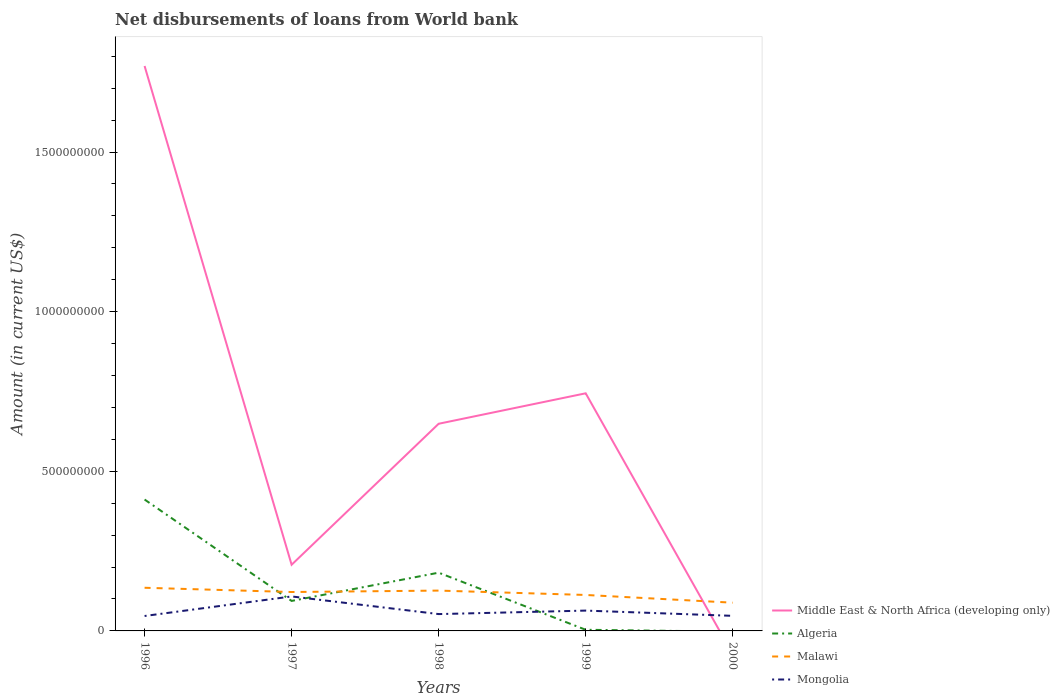How many different coloured lines are there?
Provide a short and direct response. 4. Across all years, what is the maximum amount of loan disbursed from World Bank in Algeria?
Your response must be concise. 0. What is the total amount of loan disbursed from World Bank in Middle East & North Africa (developing only) in the graph?
Your answer should be compact. 1.56e+09. What is the difference between the highest and the second highest amount of loan disbursed from World Bank in Algeria?
Make the answer very short. 4.12e+08. How many lines are there?
Provide a succinct answer. 4. What is the difference between two consecutive major ticks on the Y-axis?
Keep it short and to the point. 5.00e+08. Does the graph contain grids?
Provide a succinct answer. No. Where does the legend appear in the graph?
Provide a short and direct response. Bottom right. How many legend labels are there?
Ensure brevity in your answer.  4. What is the title of the graph?
Give a very brief answer. Net disbursements of loans from World bank. What is the Amount (in current US$) of Middle East & North Africa (developing only) in 1996?
Provide a succinct answer. 1.77e+09. What is the Amount (in current US$) of Algeria in 1996?
Keep it short and to the point. 4.12e+08. What is the Amount (in current US$) of Malawi in 1996?
Your answer should be compact. 1.35e+08. What is the Amount (in current US$) of Mongolia in 1996?
Offer a terse response. 4.68e+07. What is the Amount (in current US$) in Middle East & North Africa (developing only) in 1997?
Your answer should be compact. 2.07e+08. What is the Amount (in current US$) in Algeria in 1997?
Offer a very short reply. 9.40e+07. What is the Amount (in current US$) of Malawi in 1997?
Your answer should be compact. 1.22e+08. What is the Amount (in current US$) of Mongolia in 1997?
Give a very brief answer. 1.08e+08. What is the Amount (in current US$) in Middle East & North Africa (developing only) in 1998?
Make the answer very short. 6.49e+08. What is the Amount (in current US$) in Algeria in 1998?
Keep it short and to the point. 1.82e+08. What is the Amount (in current US$) of Malawi in 1998?
Your answer should be compact. 1.26e+08. What is the Amount (in current US$) of Mongolia in 1998?
Offer a very short reply. 5.27e+07. What is the Amount (in current US$) of Middle East & North Africa (developing only) in 1999?
Provide a short and direct response. 7.44e+08. What is the Amount (in current US$) of Algeria in 1999?
Keep it short and to the point. 3.60e+06. What is the Amount (in current US$) in Malawi in 1999?
Give a very brief answer. 1.13e+08. What is the Amount (in current US$) of Mongolia in 1999?
Make the answer very short. 6.37e+07. What is the Amount (in current US$) of Algeria in 2000?
Your answer should be very brief. 0. What is the Amount (in current US$) of Malawi in 2000?
Your answer should be compact. 8.84e+07. What is the Amount (in current US$) in Mongolia in 2000?
Your answer should be compact. 4.72e+07. Across all years, what is the maximum Amount (in current US$) of Middle East & North Africa (developing only)?
Ensure brevity in your answer.  1.77e+09. Across all years, what is the maximum Amount (in current US$) of Algeria?
Your answer should be compact. 4.12e+08. Across all years, what is the maximum Amount (in current US$) of Malawi?
Your response must be concise. 1.35e+08. Across all years, what is the maximum Amount (in current US$) of Mongolia?
Keep it short and to the point. 1.08e+08. Across all years, what is the minimum Amount (in current US$) of Algeria?
Keep it short and to the point. 0. Across all years, what is the minimum Amount (in current US$) in Malawi?
Your response must be concise. 8.84e+07. Across all years, what is the minimum Amount (in current US$) in Mongolia?
Make the answer very short. 4.68e+07. What is the total Amount (in current US$) of Middle East & North Africa (developing only) in the graph?
Give a very brief answer. 3.37e+09. What is the total Amount (in current US$) of Algeria in the graph?
Make the answer very short. 6.92e+08. What is the total Amount (in current US$) in Malawi in the graph?
Give a very brief answer. 5.84e+08. What is the total Amount (in current US$) in Mongolia in the graph?
Offer a terse response. 3.18e+08. What is the difference between the Amount (in current US$) of Middle East & North Africa (developing only) in 1996 and that in 1997?
Your response must be concise. 1.56e+09. What is the difference between the Amount (in current US$) in Algeria in 1996 and that in 1997?
Your response must be concise. 3.18e+08. What is the difference between the Amount (in current US$) in Malawi in 1996 and that in 1997?
Provide a succinct answer. 1.33e+07. What is the difference between the Amount (in current US$) in Mongolia in 1996 and that in 1997?
Your answer should be compact. -6.12e+07. What is the difference between the Amount (in current US$) in Middle East & North Africa (developing only) in 1996 and that in 1998?
Offer a terse response. 1.12e+09. What is the difference between the Amount (in current US$) in Algeria in 1996 and that in 1998?
Make the answer very short. 2.29e+08. What is the difference between the Amount (in current US$) of Malawi in 1996 and that in 1998?
Ensure brevity in your answer.  8.83e+06. What is the difference between the Amount (in current US$) of Mongolia in 1996 and that in 1998?
Ensure brevity in your answer.  -5.97e+06. What is the difference between the Amount (in current US$) of Middle East & North Africa (developing only) in 1996 and that in 1999?
Offer a terse response. 1.03e+09. What is the difference between the Amount (in current US$) in Algeria in 1996 and that in 1999?
Make the answer very short. 4.08e+08. What is the difference between the Amount (in current US$) in Malawi in 1996 and that in 1999?
Make the answer very short. 2.25e+07. What is the difference between the Amount (in current US$) in Mongolia in 1996 and that in 1999?
Keep it short and to the point. -1.69e+07. What is the difference between the Amount (in current US$) in Malawi in 1996 and that in 2000?
Keep it short and to the point. 4.67e+07. What is the difference between the Amount (in current US$) in Mongolia in 1996 and that in 2000?
Offer a very short reply. -4.84e+05. What is the difference between the Amount (in current US$) in Middle East & North Africa (developing only) in 1997 and that in 1998?
Provide a succinct answer. -4.42e+08. What is the difference between the Amount (in current US$) of Algeria in 1997 and that in 1998?
Ensure brevity in your answer.  -8.85e+07. What is the difference between the Amount (in current US$) of Malawi in 1997 and that in 1998?
Offer a very short reply. -4.47e+06. What is the difference between the Amount (in current US$) of Mongolia in 1997 and that in 1998?
Give a very brief answer. 5.53e+07. What is the difference between the Amount (in current US$) in Middle East & North Africa (developing only) in 1997 and that in 1999?
Your answer should be very brief. -5.37e+08. What is the difference between the Amount (in current US$) in Algeria in 1997 and that in 1999?
Keep it short and to the point. 9.04e+07. What is the difference between the Amount (in current US$) of Malawi in 1997 and that in 1999?
Make the answer very short. 9.22e+06. What is the difference between the Amount (in current US$) in Mongolia in 1997 and that in 1999?
Your answer should be very brief. 4.43e+07. What is the difference between the Amount (in current US$) in Malawi in 1997 and that in 2000?
Ensure brevity in your answer.  3.34e+07. What is the difference between the Amount (in current US$) in Mongolia in 1997 and that in 2000?
Offer a very short reply. 6.07e+07. What is the difference between the Amount (in current US$) of Middle East & North Africa (developing only) in 1998 and that in 1999?
Keep it short and to the point. -9.54e+07. What is the difference between the Amount (in current US$) of Algeria in 1998 and that in 1999?
Provide a succinct answer. 1.79e+08. What is the difference between the Amount (in current US$) of Malawi in 1998 and that in 1999?
Offer a very short reply. 1.37e+07. What is the difference between the Amount (in current US$) in Mongolia in 1998 and that in 1999?
Your answer should be compact. -1.09e+07. What is the difference between the Amount (in current US$) in Malawi in 1998 and that in 2000?
Ensure brevity in your answer.  3.79e+07. What is the difference between the Amount (in current US$) of Mongolia in 1998 and that in 2000?
Provide a succinct answer. 5.49e+06. What is the difference between the Amount (in current US$) of Malawi in 1999 and that in 2000?
Provide a short and direct response. 2.42e+07. What is the difference between the Amount (in current US$) in Mongolia in 1999 and that in 2000?
Make the answer very short. 1.64e+07. What is the difference between the Amount (in current US$) of Middle East & North Africa (developing only) in 1996 and the Amount (in current US$) of Algeria in 1997?
Offer a terse response. 1.68e+09. What is the difference between the Amount (in current US$) of Middle East & North Africa (developing only) in 1996 and the Amount (in current US$) of Malawi in 1997?
Offer a very short reply. 1.65e+09. What is the difference between the Amount (in current US$) in Middle East & North Africa (developing only) in 1996 and the Amount (in current US$) in Mongolia in 1997?
Your answer should be very brief. 1.66e+09. What is the difference between the Amount (in current US$) of Algeria in 1996 and the Amount (in current US$) of Malawi in 1997?
Your response must be concise. 2.90e+08. What is the difference between the Amount (in current US$) of Algeria in 1996 and the Amount (in current US$) of Mongolia in 1997?
Your response must be concise. 3.04e+08. What is the difference between the Amount (in current US$) of Malawi in 1996 and the Amount (in current US$) of Mongolia in 1997?
Your answer should be very brief. 2.72e+07. What is the difference between the Amount (in current US$) in Middle East & North Africa (developing only) in 1996 and the Amount (in current US$) in Algeria in 1998?
Your answer should be very brief. 1.59e+09. What is the difference between the Amount (in current US$) in Middle East & North Africa (developing only) in 1996 and the Amount (in current US$) in Malawi in 1998?
Make the answer very short. 1.64e+09. What is the difference between the Amount (in current US$) of Middle East & North Africa (developing only) in 1996 and the Amount (in current US$) of Mongolia in 1998?
Make the answer very short. 1.72e+09. What is the difference between the Amount (in current US$) in Algeria in 1996 and the Amount (in current US$) in Malawi in 1998?
Make the answer very short. 2.85e+08. What is the difference between the Amount (in current US$) of Algeria in 1996 and the Amount (in current US$) of Mongolia in 1998?
Provide a succinct answer. 3.59e+08. What is the difference between the Amount (in current US$) of Malawi in 1996 and the Amount (in current US$) of Mongolia in 1998?
Make the answer very short. 8.24e+07. What is the difference between the Amount (in current US$) in Middle East & North Africa (developing only) in 1996 and the Amount (in current US$) in Algeria in 1999?
Keep it short and to the point. 1.77e+09. What is the difference between the Amount (in current US$) in Middle East & North Africa (developing only) in 1996 and the Amount (in current US$) in Malawi in 1999?
Provide a short and direct response. 1.66e+09. What is the difference between the Amount (in current US$) of Middle East & North Africa (developing only) in 1996 and the Amount (in current US$) of Mongolia in 1999?
Ensure brevity in your answer.  1.71e+09. What is the difference between the Amount (in current US$) of Algeria in 1996 and the Amount (in current US$) of Malawi in 1999?
Provide a short and direct response. 2.99e+08. What is the difference between the Amount (in current US$) of Algeria in 1996 and the Amount (in current US$) of Mongolia in 1999?
Make the answer very short. 3.48e+08. What is the difference between the Amount (in current US$) in Malawi in 1996 and the Amount (in current US$) in Mongolia in 1999?
Provide a short and direct response. 7.15e+07. What is the difference between the Amount (in current US$) in Middle East & North Africa (developing only) in 1996 and the Amount (in current US$) in Malawi in 2000?
Offer a very short reply. 1.68e+09. What is the difference between the Amount (in current US$) in Middle East & North Africa (developing only) in 1996 and the Amount (in current US$) in Mongolia in 2000?
Provide a short and direct response. 1.72e+09. What is the difference between the Amount (in current US$) of Algeria in 1996 and the Amount (in current US$) of Malawi in 2000?
Your answer should be compact. 3.23e+08. What is the difference between the Amount (in current US$) of Algeria in 1996 and the Amount (in current US$) of Mongolia in 2000?
Offer a very short reply. 3.64e+08. What is the difference between the Amount (in current US$) in Malawi in 1996 and the Amount (in current US$) in Mongolia in 2000?
Ensure brevity in your answer.  8.79e+07. What is the difference between the Amount (in current US$) in Middle East & North Africa (developing only) in 1997 and the Amount (in current US$) in Algeria in 1998?
Offer a terse response. 2.48e+07. What is the difference between the Amount (in current US$) in Middle East & North Africa (developing only) in 1997 and the Amount (in current US$) in Malawi in 1998?
Give a very brief answer. 8.09e+07. What is the difference between the Amount (in current US$) of Middle East & North Africa (developing only) in 1997 and the Amount (in current US$) of Mongolia in 1998?
Provide a short and direct response. 1.55e+08. What is the difference between the Amount (in current US$) of Algeria in 1997 and the Amount (in current US$) of Malawi in 1998?
Your answer should be very brief. -3.24e+07. What is the difference between the Amount (in current US$) of Algeria in 1997 and the Amount (in current US$) of Mongolia in 1998?
Provide a succinct answer. 4.12e+07. What is the difference between the Amount (in current US$) in Malawi in 1997 and the Amount (in current US$) in Mongolia in 1998?
Provide a short and direct response. 6.91e+07. What is the difference between the Amount (in current US$) in Middle East & North Africa (developing only) in 1997 and the Amount (in current US$) in Algeria in 1999?
Provide a succinct answer. 2.04e+08. What is the difference between the Amount (in current US$) of Middle East & North Africa (developing only) in 1997 and the Amount (in current US$) of Malawi in 1999?
Provide a short and direct response. 9.46e+07. What is the difference between the Amount (in current US$) in Middle East & North Africa (developing only) in 1997 and the Amount (in current US$) in Mongolia in 1999?
Offer a very short reply. 1.44e+08. What is the difference between the Amount (in current US$) in Algeria in 1997 and the Amount (in current US$) in Malawi in 1999?
Ensure brevity in your answer.  -1.87e+07. What is the difference between the Amount (in current US$) of Algeria in 1997 and the Amount (in current US$) of Mongolia in 1999?
Provide a short and direct response. 3.03e+07. What is the difference between the Amount (in current US$) in Malawi in 1997 and the Amount (in current US$) in Mongolia in 1999?
Keep it short and to the point. 5.82e+07. What is the difference between the Amount (in current US$) in Middle East & North Africa (developing only) in 1997 and the Amount (in current US$) in Malawi in 2000?
Provide a short and direct response. 1.19e+08. What is the difference between the Amount (in current US$) of Middle East & North Africa (developing only) in 1997 and the Amount (in current US$) of Mongolia in 2000?
Ensure brevity in your answer.  1.60e+08. What is the difference between the Amount (in current US$) in Algeria in 1997 and the Amount (in current US$) in Malawi in 2000?
Provide a short and direct response. 5.52e+06. What is the difference between the Amount (in current US$) of Algeria in 1997 and the Amount (in current US$) of Mongolia in 2000?
Offer a very short reply. 4.67e+07. What is the difference between the Amount (in current US$) of Malawi in 1997 and the Amount (in current US$) of Mongolia in 2000?
Offer a very short reply. 7.46e+07. What is the difference between the Amount (in current US$) in Middle East & North Africa (developing only) in 1998 and the Amount (in current US$) in Algeria in 1999?
Keep it short and to the point. 6.45e+08. What is the difference between the Amount (in current US$) of Middle East & North Africa (developing only) in 1998 and the Amount (in current US$) of Malawi in 1999?
Offer a very short reply. 5.36e+08. What is the difference between the Amount (in current US$) of Middle East & North Africa (developing only) in 1998 and the Amount (in current US$) of Mongolia in 1999?
Your answer should be compact. 5.85e+08. What is the difference between the Amount (in current US$) in Algeria in 1998 and the Amount (in current US$) in Malawi in 1999?
Make the answer very short. 6.98e+07. What is the difference between the Amount (in current US$) in Algeria in 1998 and the Amount (in current US$) in Mongolia in 1999?
Your answer should be very brief. 1.19e+08. What is the difference between the Amount (in current US$) of Malawi in 1998 and the Amount (in current US$) of Mongolia in 1999?
Offer a very short reply. 6.27e+07. What is the difference between the Amount (in current US$) of Middle East & North Africa (developing only) in 1998 and the Amount (in current US$) of Malawi in 2000?
Keep it short and to the point. 5.60e+08. What is the difference between the Amount (in current US$) of Middle East & North Africa (developing only) in 1998 and the Amount (in current US$) of Mongolia in 2000?
Offer a terse response. 6.02e+08. What is the difference between the Amount (in current US$) in Algeria in 1998 and the Amount (in current US$) in Malawi in 2000?
Give a very brief answer. 9.40e+07. What is the difference between the Amount (in current US$) in Algeria in 1998 and the Amount (in current US$) in Mongolia in 2000?
Your response must be concise. 1.35e+08. What is the difference between the Amount (in current US$) of Malawi in 1998 and the Amount (in current US$) of Mongolia in 2000?
Make the answer very short. 7.91e+07. What is the difference between the Amount (in current US$) in Middle East & North Africa (developing only) in 1999 and the Amount (in current US$) in Malawi in 2000?
Offer a terse response. 6.56e+08. What is the difference between the Amount (in current US$) of Middle East & North Africa (developing only) in 1999 and the Amount (in current US$) of Mongolia in 2000?
Your answer should be very brief. 6.97e+08. What is the difference between the Amount (in current US$) of Algeria in 1999 and the Amount (in current US$) of Malawi in 2000?
Give a very brief answer. -8.48e+07. What is the difference between the Amount (in current US$) of Algeria in 1999 and the Amount (in current US$) of Mongolia in 2000?
Your answer should be very brief. -4.36e+07. What is the difference between the Amount (in current US$) in Malawi in 1999 and the Amount (in current US$) in Mongolia in 2000?
Your answer should be compact. 6.54e+07. What is the average Amount (in current US$) in Middle East & North Africa (developing only) per year?
Your response must be concise. 6.74e+08. What is the average Amount (in current US$) in Algeria per year?
Your answer should be compact. 1.38e+08. What is the average Amount (in current US$) of Malawi per year?
Ensure brevity in your answer.  1.17e+08. What is the average Amount (in current US$) in Mongolia per year?
Your answer should be very brief. 6.37e+07. In the year 1996, what is the difference between the Amount (in current US$) of Middle East & North Africa (developing only) and Amount (in current US$) of Algeria?
Keep it short and to the point. 1.36e+09. In the year 1996, what is the difference between the Amount (in current US$) in Middle East & North Africa (developing only) and Amount (in current US$) in Malawi?
Your answer should be compact. 1.63e+09. In the year 1996, what is the difference between the Amount (in current US$) of Middle East & North Africa (developing only) and Amount (in current US$) of Mongolia?
Make the answer very short. 1.72e+09. In the year 1996, what is the difference between the Amount (in current US$) of Algeria and Amount (in current US$) of Malawi?
Offer a terse response. 2.76e+08. In the year 1996, what is the difference between the Amount (in current US$) of Algeria and Amount (in current US$) of Mongolia?
Provide a succinct answer. 3.65e+08. In the year 1996, what is the difference between the Amount (in current US$) in Malawi and Amount (in current US$) in Mongolia?
Ensure brevity in your answer.  8.84e+07. In the year 1997, what is the difference between the Amount (in current US$) of Middle East & North Africa (developing only) and Amount (in current US$) of Algeria?
Your response must be concise. 1.13e+08. In the year 1997, what is the difference between the Amount (in current US$) in Middle East & North Africa (developing only) and Amount (in current US$) in Malawi?
Offer a very short reply. 8.54e+07. In the year 1997, what is the difference between the Amount (in current US$) of Middle East & North Africa (developing only) and Amount (in current US$) of Mongolia?
Your answer should be very brief. 9.93e+07. In the year 1997, what is the difference between the Amount (in current US$) in Algeria and Amount (in current US$) in Malawi?
Offer a terse response. -2.79e+07. In the year 1997, what is the difference between the Amount (in current US$) of Algeria and Amount (in current US$) of Mongolia?
Offer a terse response. -1.40e+07. In the year 1997, what is the difference between the Amount (in current US$) in Malawi and Amount (in current US$) in Mongolia?
Provide a short and direct response. 1.39e+07. In the year 1998, what is the difference between the Amount (in current US$) of Middle East & North Africa (developing only) and Amount (in current US$) of Algeria?
Keep it short and to the point. 4.66e+08. In the year 1998, what is the difference between the Amount (in current US$) of Middle East & North Africa (developing only) and Amount (in current US$) of Malawi?
Your answer should be compact. 5.23e+08. In the year 1998, what is the difference between the Amount (in current US$) of Middle East & North Africa (developing only) and Amount (in current US$) of Mongolia?
Your answer should be very brief. 5.96e+08. In the year 1998, what is the difference between the Amount (in current US$) of Algeria and Amount (in current US$) of Malawi?
Your response must be concise. 5.61e+07. In the year 1998, what is the difference between the Amount (in current US$) in Algeria and Amount (in current US$) in Mongolia?
Give a very brief answer. 1.30e+08. In the year 1998, what is the difference between the Amount (in current US$) of Malawi and Amount (in current US$) of Mongolia?
Make the answer very short. 7.36e+07. In the year 1999, what is the difference between the Amount (in current US$) in Middle East & North Africa (developing only) and Amount (in current US$) in Algeria?
Your response must be concise. 7.41e+08. In the year 1999, what is the difference between the Amount (in current US$) of Middle East & North Africa (developing only) and Amount (in current US$) of Malawi?
Make the answer very short. 6.32e+08. In the year 1999, what is the difference between the Amount (in current US$) in Middle East & North Africa (developing only) and Amount (in current US$) in Mongolia?
Your response must be concise. 6.81e+08. In the year 1999, what is the difference between the Amount (in current US$) in Algeria and Amount (in current US$) in Malawi?
Give a very brief answer. -1.09e+08. In the year 1999, what is the difference between the Amount (in current US$) of Algeria and Amount (in current US$) of Mongolia?
Ensure brevity in your answer.  -6.01e+07. In the year 1999, what is the difference between the Amount (in current US$) of Malawi and Amount (in current US$) of Mongolia?
Offer a terse response. 4.90e+07. In the year 2000, what is the difference between the Amount (in current US$) in Malawi and Amount (in current US$) in Mongolia?
Provide a short and direct response. 4.12e+07. What is the ratio of the Amount (in current US$) of Middle East & North Africa (developing only) in 1996 to that in 1997?
Offer a terse response. 8.54. What is the ratio of the Amount (in current US$) of Algeria in 1996 to that in 1997?
Your response must be concise. 4.38. What is the ratio of the Amount (in current US$) in Malawi in 1996 to that in 1997?
Make the answer very short. 1.11. What is the ratio of the Amount (in current US$) in Mongolia in 1996 to that in 1997?
Make the answer very short. 0.43. What is the ratio of the Amount (in current US$) in Middle East & North Africa (developing only) in 1996 to that in 1998?
Keep it short and to the point. 2.73. What is the ratio of the Amount (in current US$) of Algeria in 1996 to that in 1998?
Keep it short and to the point. 2.26. What is the ratio of the Amount (in current US$) in Malawi in 1996 to that in 1998?
Give a very brief answer. 1.07. What is the ratio of the Amount (in current US$) in Mongolia in 1996 to that in 1998?
Your response must be concise. 0.89. What is the ratio of the Amount (in current US$) of Middle East & North Africa (developing only) in 1996 to that in 1999?
Offer a very short reply. 2.38. What is the ratio of the Amount (in current US$) of Algeria in 1996 to that in 1999?
Make the answer very short. 114.17. What is the ratio of the Amount (in current US$) of Mongolia in 1996 to that in 1999?
Your answer should be very brief. 0.73. What is the ratio of the Amount (in current US$) of Malawi in 1996 to that in 2000?
Make the answer very short. 1.53. What is the ratio of the Amount (in current US$) in Middle East & North Africa (developing only) in 1997 to that in 1998?
Your answer should be very brief. 0.32. What is the ratio of the Amount (in current US$) of Algeria in 1997 to that in 1998?
Provide a succinct answer. 0.52. What is the ratio of the Amount (in current US$) of Malawi in 1997 to that in 1998?
Offer a terse response. 0.96. What is the ratio of the Amount (in current US$) of Mongolia in 1997 to that in 1998?
Offer a terse response. 2.05. What is the ratio of the Amount (in current US$) of Middle East & North Africa (developing only) in 1997 to that in 1999?
Offer a very short reply. 0.28. What is the ratio of the Amount (in current US$) in Algeria in 1997 to that in 1999?
Provide a short and direct response. 26.06. What is the ratio of the Amount (in current US$) in Malawi in 1997 to that in 1999?
Provide a short and direct response. 1.08. What is the ratio of the Amount (in current US$) in Mongolia in 1997 to that in 1999?
Keep it short and to the point. 1.7. What is the ratio of the Amount (in current US$) of Malawi in 1997 to that in 2000?
Provide a short and direct response. 1.38. What is the ratio of the Amount (in current US$) of Mongolia in 1997 to that in 2000?
Your answer should be very brief. 2.29. What is the ratio of the Amount (in current US$) of Middle East & North Africa (developing only) in 1998 to that in 1999?
Your answer should be very brief. 0.87. What is the ratio of the Amount (in current US$) of Algeria in 1998 to that in 1999?
Offer a very short reply. 50.61. What is the ratio of the Amount (in current US$) in Malawi in 1998 to that in 1999?
Offer a terse response. 1.12. What is the ratio of the Amount (in current US$) in Mongolia in 1998 to that in 1999?
Offer a very short reply. 0.83. What is the ratio of the Amount (in current US$) in Malawi in 1998 to that in 2000?
Give a very brief answer. 1.43. What is the ratio of the Amount (in current US$) of Mongolia in 1998 to that in 2000?
Make the answer very short. 1.12. What is the ratio of the Amount (in current US$) of Malawi in 1999 to that in 2000?
Give a very brief answer. 1.27. What is the ratio of the Amount (in current US$) in Mongolia in 1999 to that in 2000?
Keep it short and to the point. 1.35. What is the difference between the highest and the second highest Amount (in current US$) in Middle East & North Africa (developing only)?
Your answer should be very brief. 1.03e+09. What is the difference between the highest and the second highest Amount (in current US$) in Algeria?
Offer a terse response. 2.29e+08. What is the difference between the highest and the second highest Amount (in current US$) of Malawi?
Provide a short and direct response. 8.83e+06. What is the difference between the highest and the second highest Amount (in current US$) in Mongolia?
Provide a short and direct response. 4.43e+07. What is the difference between the highest and the lowest Amount (in current US$) in Middle East & North Africa (developing only)?
Your response must be concise. 1.77e+09. What is the difference between the highest and the lowest Amount (in current US$) of Algeria?
Your answer should be compact. 4.12e+08. What is the difference between the highest and the lowest Amount (in current US$) of Malawi?
Offer a very short reply. 4.67e+07. What is the difference between the highest and the lowest Amount (in current US$) of Mongolia?
Your answer should be very brief. 6.12e+07. 